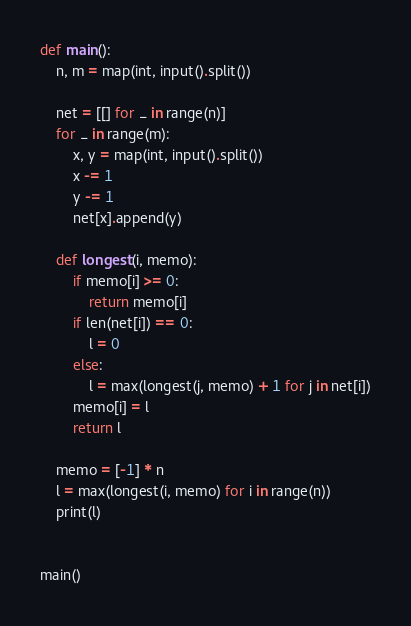Convert code to text. <code><loc_0><loc_0><loc_500><loc_500><_Python_>def main():
    n, m = map(int, input().split())

    net = [[] for _ in range(n)]
    for _ in range(m):
        x, y = map(int, input().split())
        x -= 1
        y -= 1
        net[x].append(y)

    def longest(i, memo):
        if memo[i] >= 0:
            return memo[i]
        if len(net[i]) == 0:
            l = 0
        else:
            l = max(longest(j, memo) + 1 for j in net[i])
        memo[i] = l
        return l

    memo = [-1] * n
    l = max(longest(i, memo) for i in range(n))
    print(l)


main()
</code> 